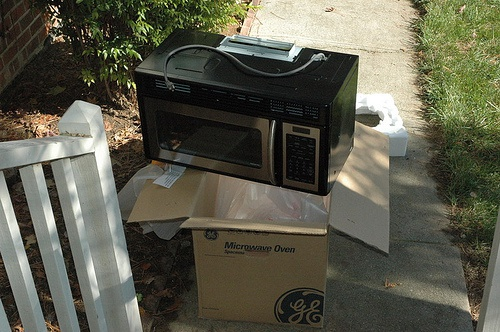Describe the objects in this image and their specific colors. I can see a microwave in black, gray, darkgreen, and darkgray tones in this image. 